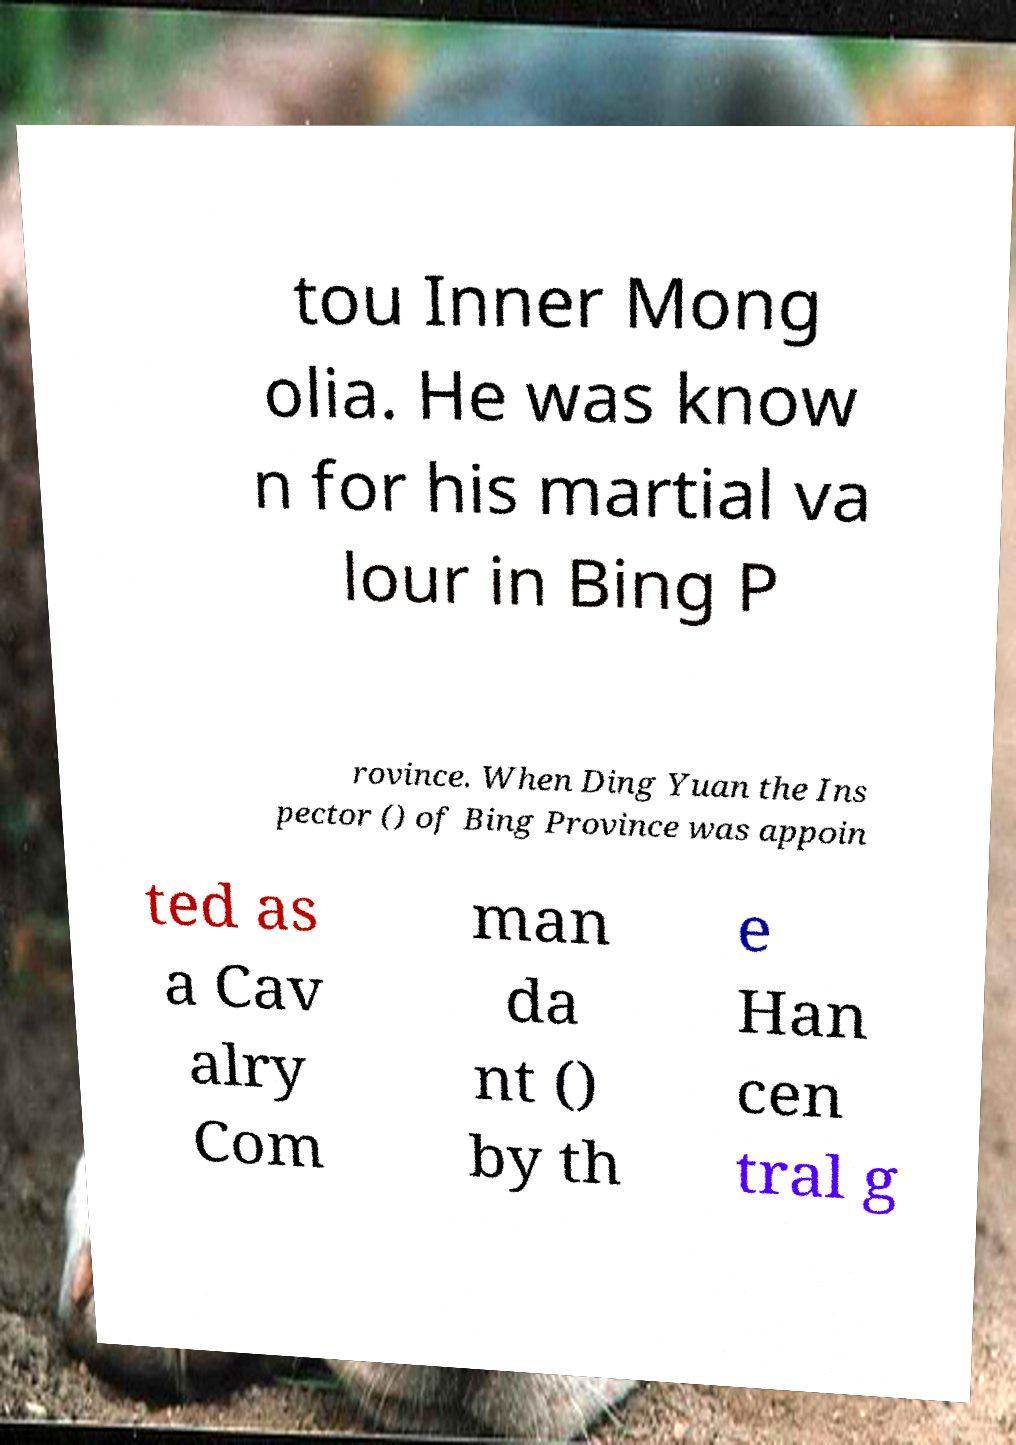Please identify and transcribe the text found in this image. tou Inner Mong olia. He was know n for his martial va lour in Bing P rovince. When Ding Yuan the Ins pector () of Bing Province was appoin ted as a Cav alry Com man da nt () by th e Han cen tral g 